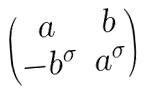Convert formula to latex. <formula><loc_0><loc_0><loc_500><loc_500>\begin{pmatrix} a & b \\ - b ^ { \sigma } & a ^ { \sigma } \end{pmatrix}</formula> 